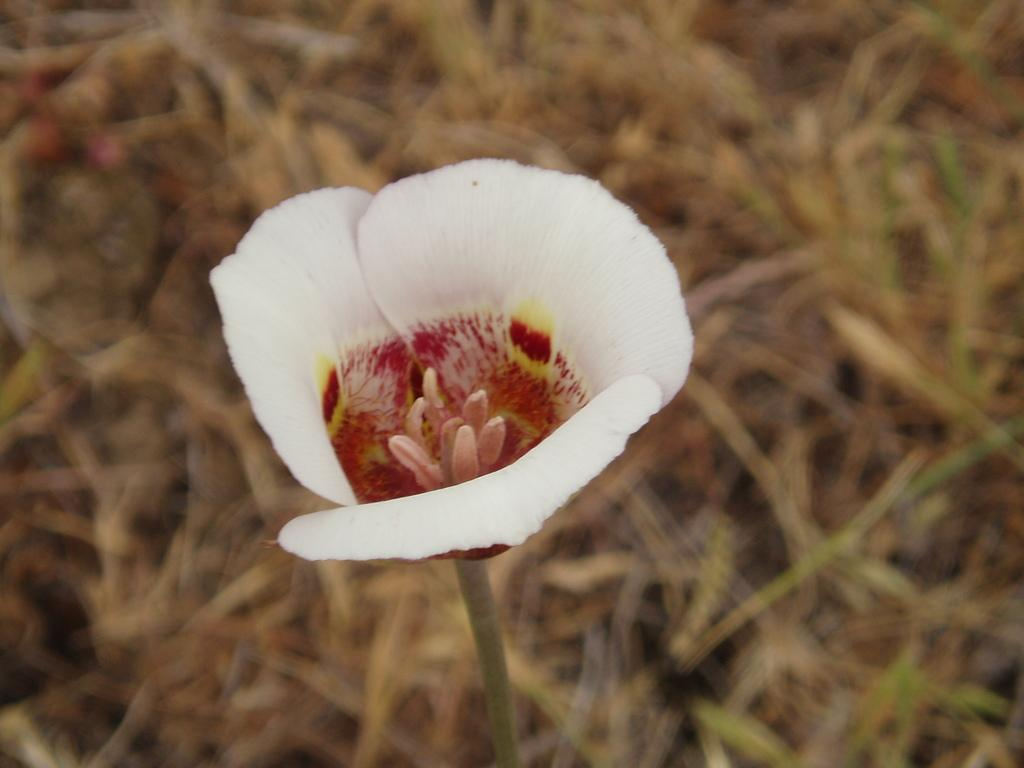What is the main subject in the foreground of the picture? There is a flower in the foreground of the picture. Can you describe the background of the image? The background of the image is blurred. What religious symbol can be seen in the background of the image? There is no religious symbol present in the image; it only features a flower in the foreground and a blurred background. Is there a monkey visible in the image? No, there is no monkey present in the image. 